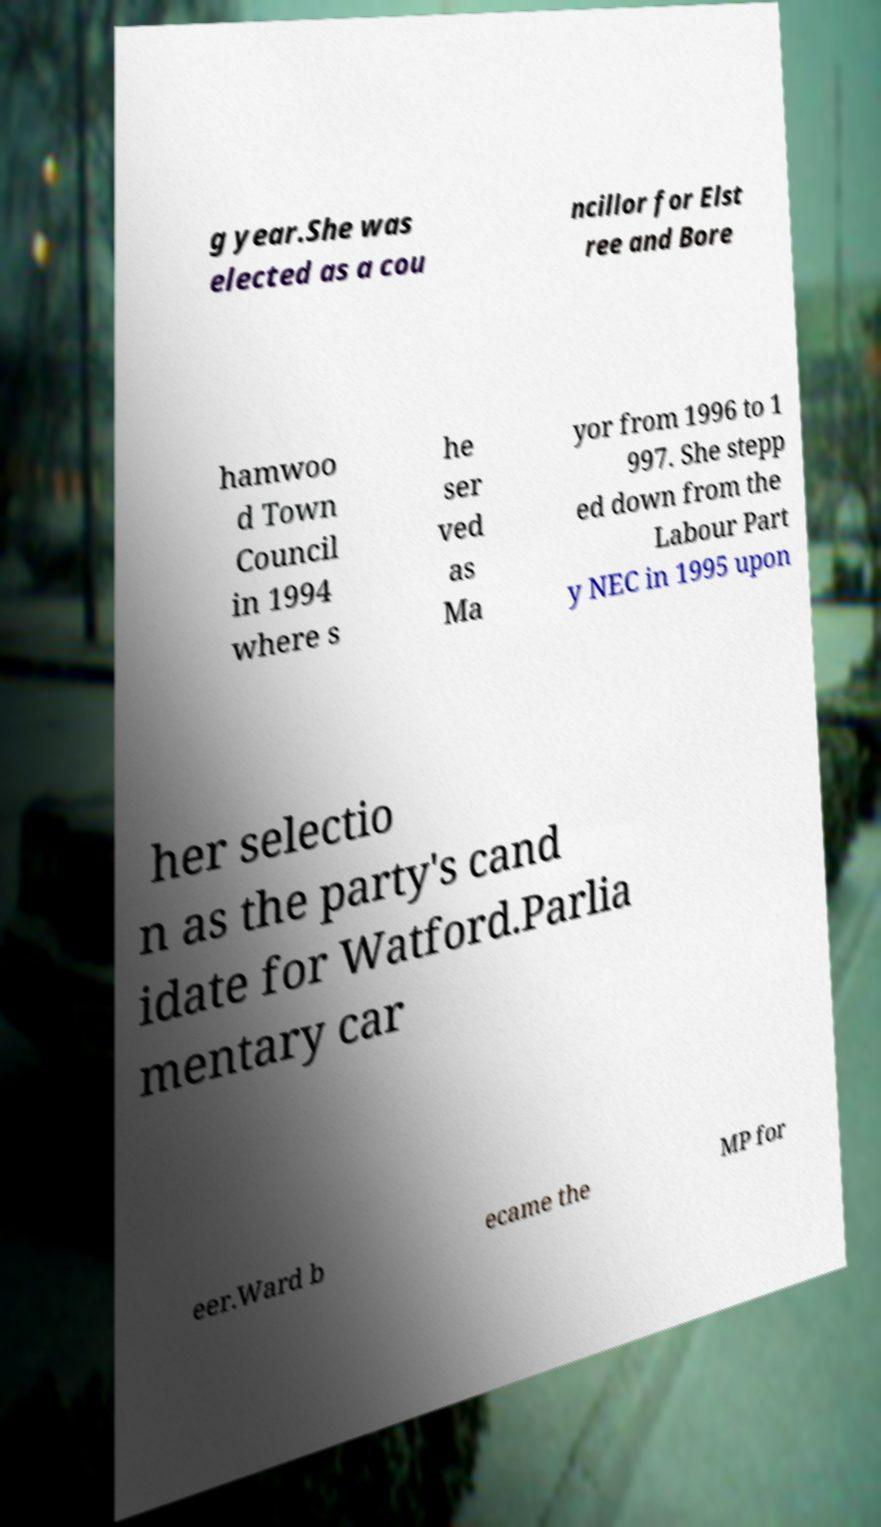Could you assist in decoding the text presented in this image and type it out clearly? g year.She was elected as a cou ncillor for Elst ree and Bore hamwoo d Town Council in 1994 where s he ser ved as Ma yor from 1996 to 1 997. She stepp ed down from the Labour Part y NEC in 1995 upon her selectio n as the party's cand idate for Watford.Parlia mentary car eer.Ward b ecame the MP for 